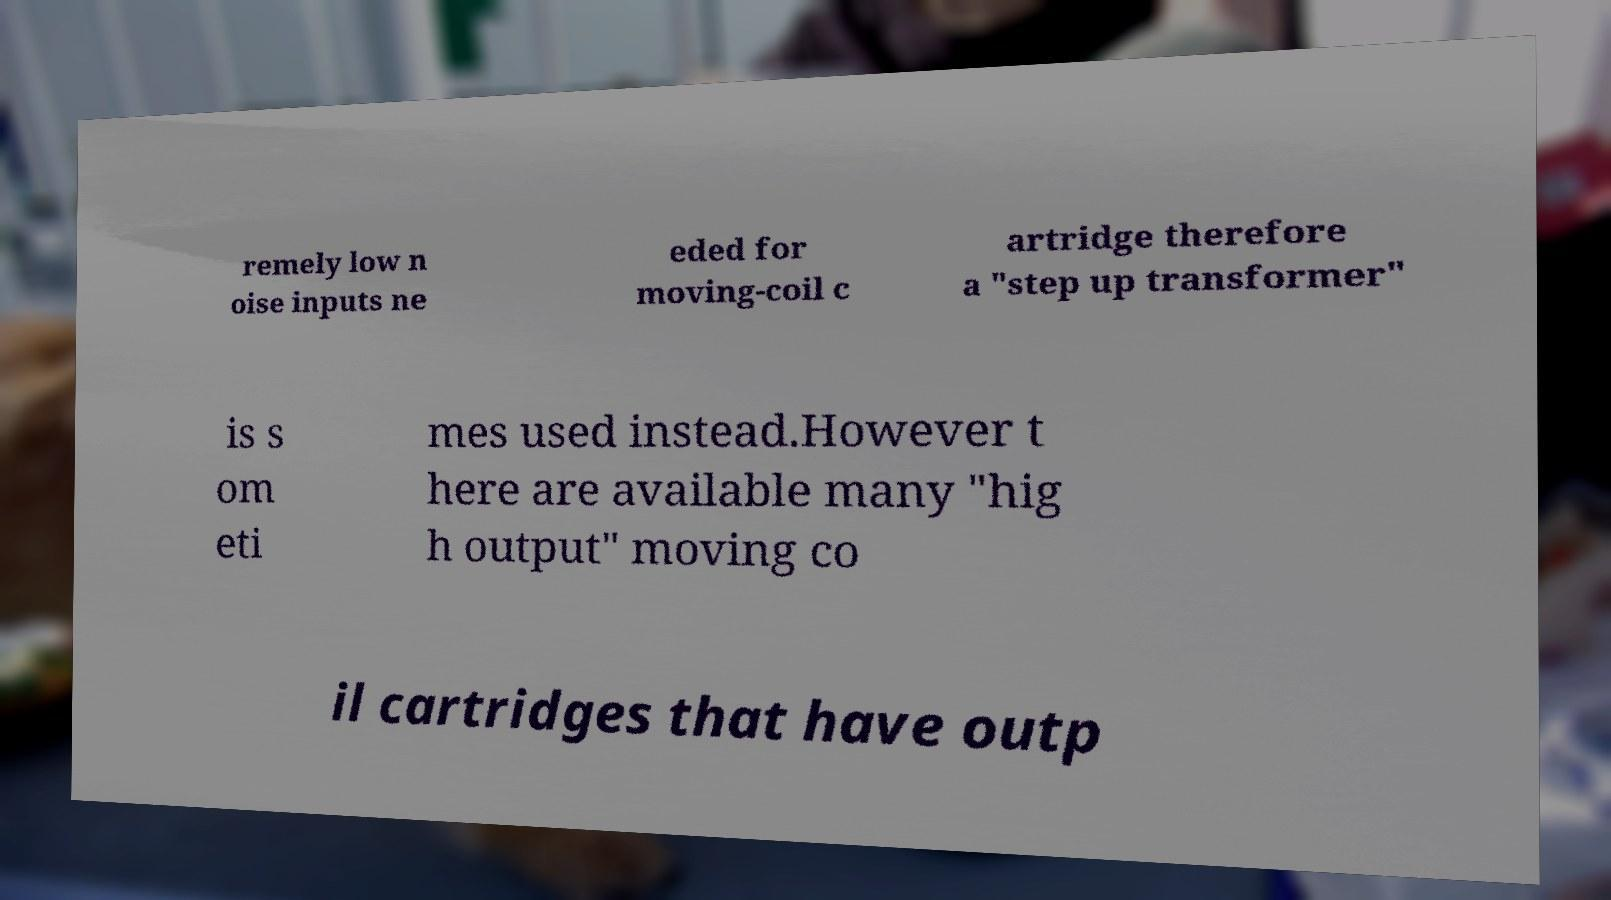For documentation purposes, I need the text within this image transcribed. Could you provide that? remely low n oise inputs ne eded for moving-coil c artridge therefore a "step up transformer" is s om eti mes used instead.However t here are available many "hig h output" moving co il cartridges that have outp 